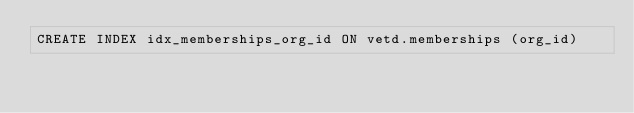<code> <loc_0><loc_0><loc_500><loc_500><_SQL_>CREATE INDEX idx_memberships_org_id ON vetd.memberships (org_id)</code> 